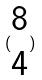Convert formula to latex. <formula><loc_0><loc_0><loc_500><loc_500>( \begin{matrix} 8 \\ 4 \end{matrix} )</formula> 